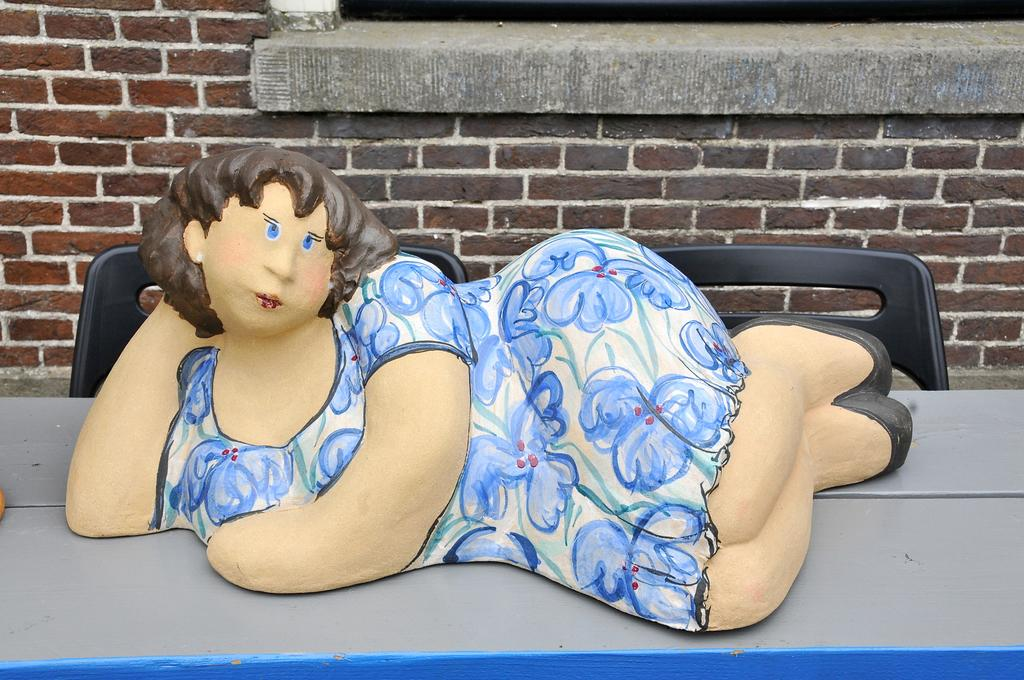What is the main object on the table in the image? There is a statue of a woman on the table. What type of furniture is visible in the image? There are chairs in the image. What is visible in the background of the image? There is a wall in the background of the image. What type of fruit is hanging from the statue in the image? There is no fruit hanging from the statue in the image; it is a statue of a woman. What art style is the statue created in? The provided facts do not give information about the art style of the statue, so it cannot be definitively determined from the image. 